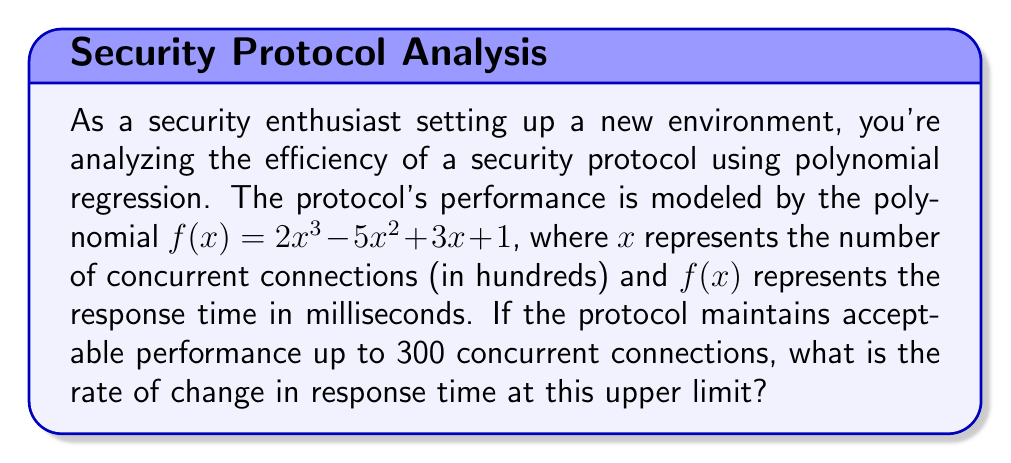Can you answer this question? To solve this problem, we need to follow these steps:

1) The polynomial representing the protocol's performance is:
   $$f(x) = 2x^3 - 5x^2 + 3x + 1$$

2) We're asked about the rate of change at 300 concurrent connections. This corresponds to $x = 3$ in our model (since $x$ is in hundreds).

3) The rate of change is represented by the derivative of the function. Let's find $f'(x)$:

   $$f'(x) = 6x^2 - 10x + 3$$

4) Now, we need to evaluate $f'(3)$:

   $$f'(3) = 6(3)^2 - 10(3) + 3$$
   $$= 6(9) - 30 + 3$$
   $$= 54 - 30 + 3$$
   $$= 27$$

5) This result represents the instantaneous rate of change in milliseconds per 100 connections.
Answer: The rate of change in response time at 300 concurrent connections is 27 milliseconds per 100 connections. 